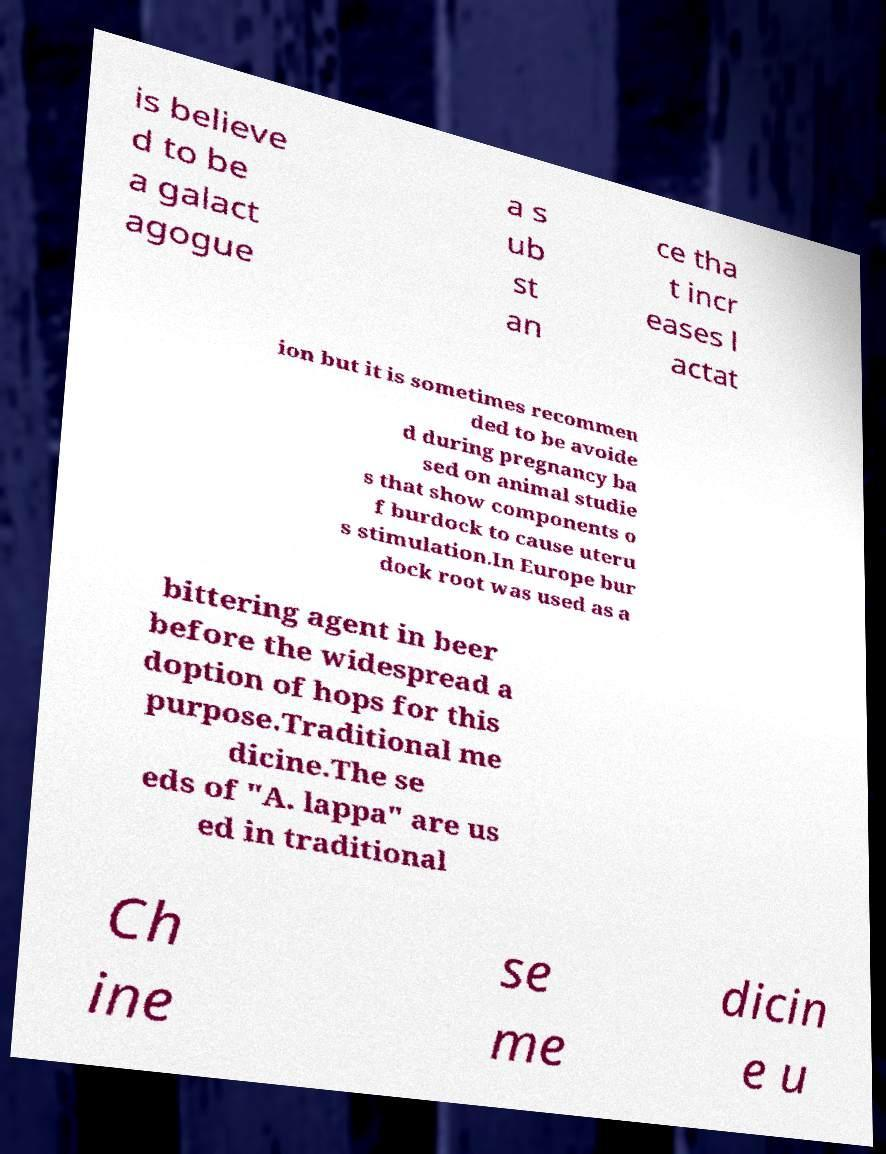What messages or text are displayed in this image? I need them in a readable, typed format. is believe d to be a galact agogue a s ub st an ce tha t incr eases l actat ion but it is sometimes recommen ded to be avoide d during pregnancy ba sed on animal studie s that show components o f burdock to cause uteru s stimulation.In Europe bur dock root was used as a bittering agent in beer before the widespread a doption of hops for this purpose.Traditional me dicine.The se eds of "A. lappa" are us ed in traditional Ch ine se me dicin e u 